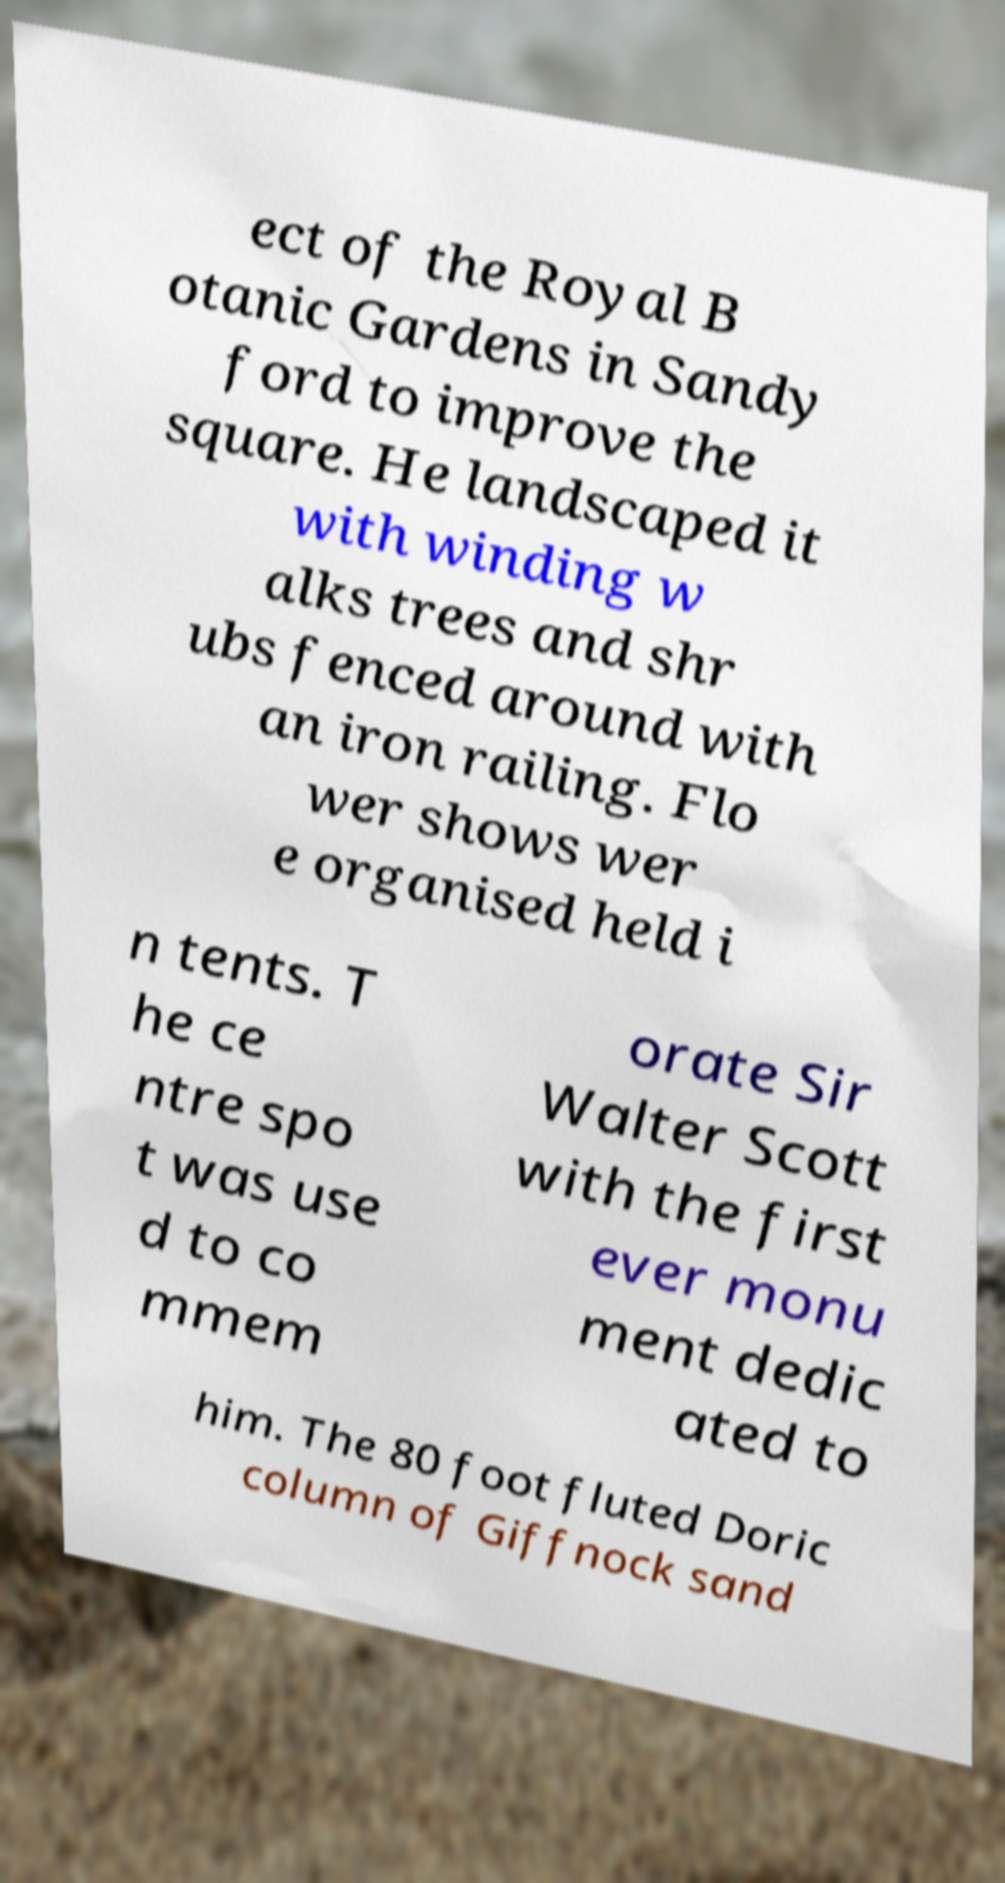Could you extract and type out the text from this image? ect of the Royal B otanic Gardens in Sandy ford to improve the square. He landscaped it with winding w alks trees and shr ubs fenced around with an iron railing. Flo wer shows wer e organised held i n tents. T he ce ntre spo t was use d to co mmem orate Sir Walter Scott with the first ever monu ment dedic ated to him. The 80 foot fluted Doric column of Giffnock sand 